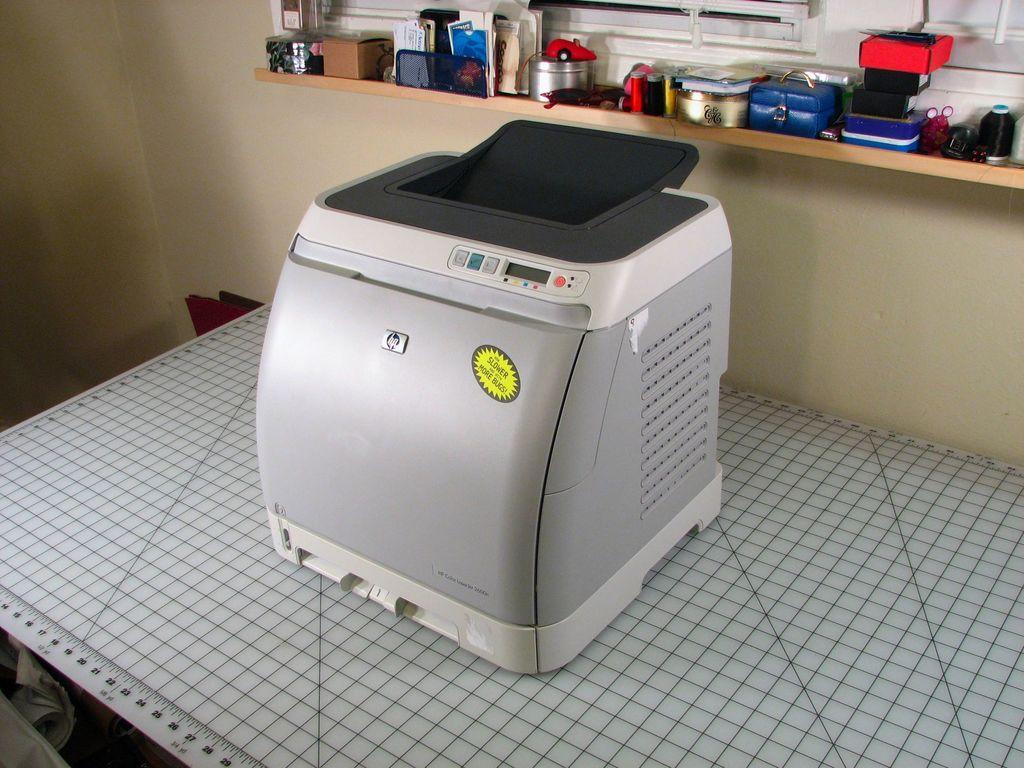How would you summarize this image in a sentence or two? In the center of the image we can see a device placed on the table. In the foreground we can see the numbers. In the background, we can see some objects placed on rack and windows. 